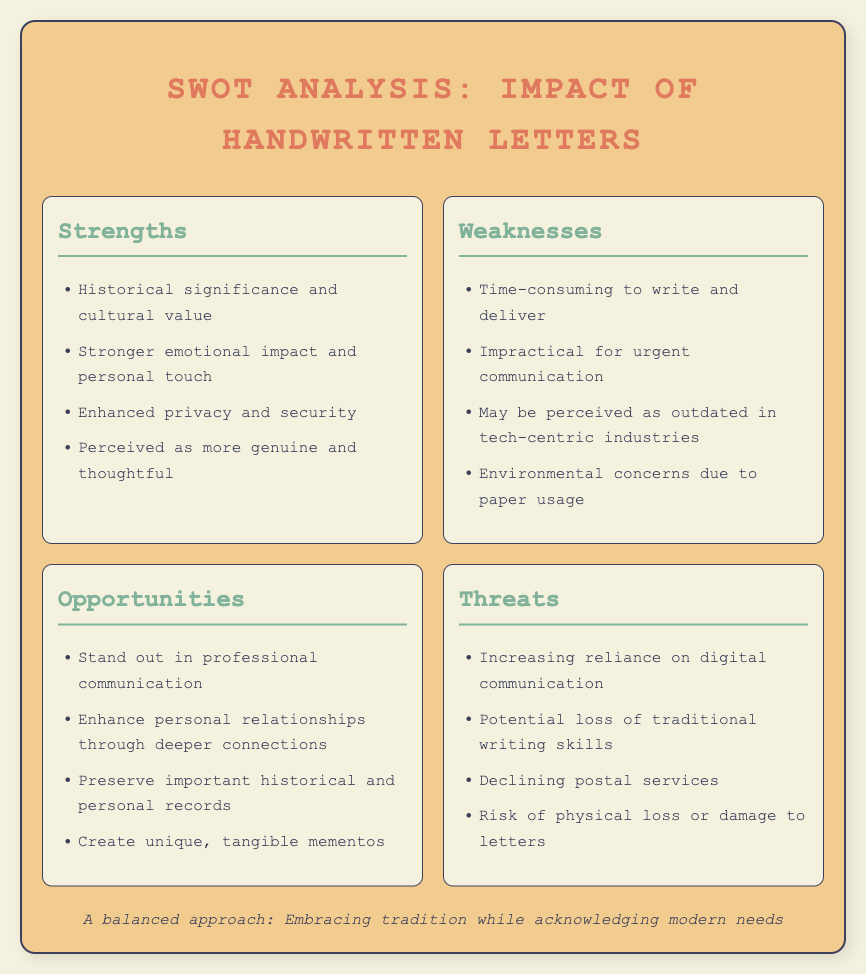what is the title of the document? The title is provided in the header section of the document.
Answer: SWOT Analysis: Impact of Handwritten Letters how many strengths are listed? The document enumerates the strengths section.
Answer: Four what is one emotional benefit of handwritten letters? The document mentions emotional aspects in the strengths section.
Answer: Stronger emotional impact and personal touch name one opportunity for handwritten letters in communication. The opportunities section outlines potential advantages for handwritten letters.
Answer: Stand out in professional communication what environmental concern is associated with handwritten letters? The weaknesses section highlights issues regarding handwriting practices.
Answer: Environmental concerns due to paper usage what is considered a threat to handwritten letters? The threats section indicates risks impacting handwritten letters.
Answer: Increasing reliance on digital communication which section describes the cultural significance of handwritten letters? The strengths section includes the cultural value of handwritten letters.
Answer: Strengths how can handwritten letters enhance personal relationships? The opportunities section highlights the potential effects on relationships.
Answer: Enhance personal relationships through deeper connections 